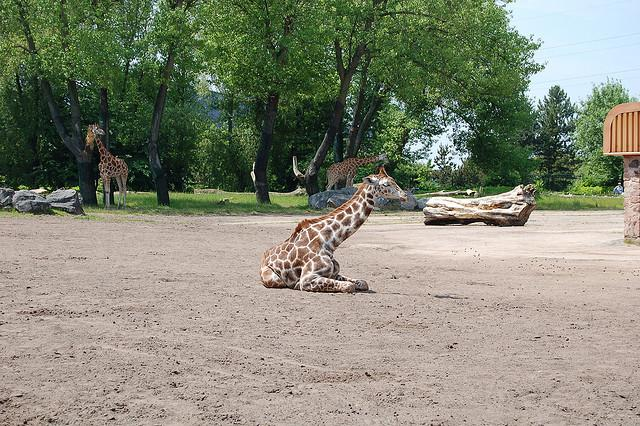What us the giraffe in the foreground sitting on?

Choices:
A) sand
B) water
C) box
D) snow sand 